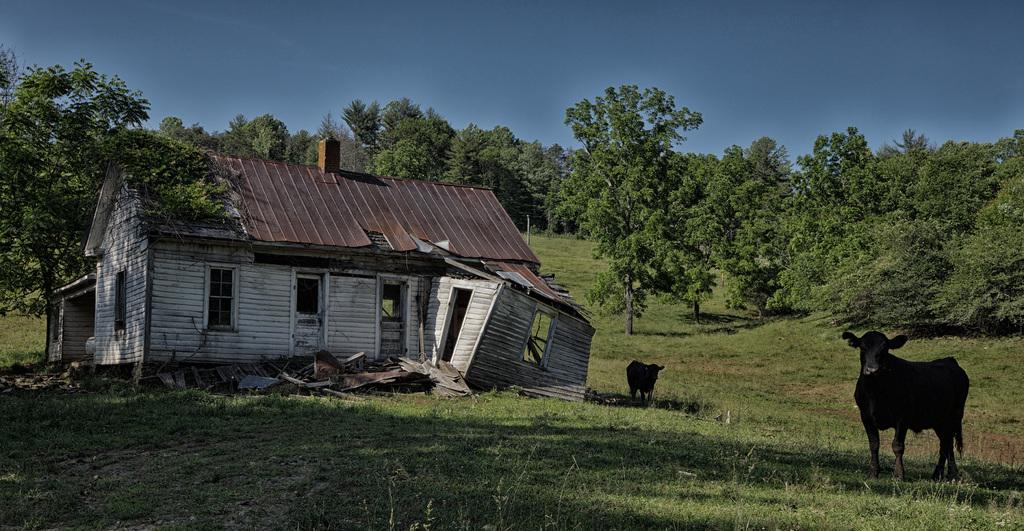What type of house is in the image? There is a wooden house in the image. What is the condition of the house? The house appears to be destroyed or damaged. What can be seen in the surroundings of the house? There is a lot of greenery around the house. How many animals are visible in the image? There are two animals visible in the image. Can you read the note that is attached to the eye of one of the animals in the image? There is no note or eye visible in the image; it only features a wooden house, greenery, and two animals. 